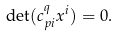Convert formula to latex. <formula><loc_0><loc_0><loc_500><loc_500>\det ( c ^ { q } _ { p i } x ^ { i } ) = 0 .</formula> 